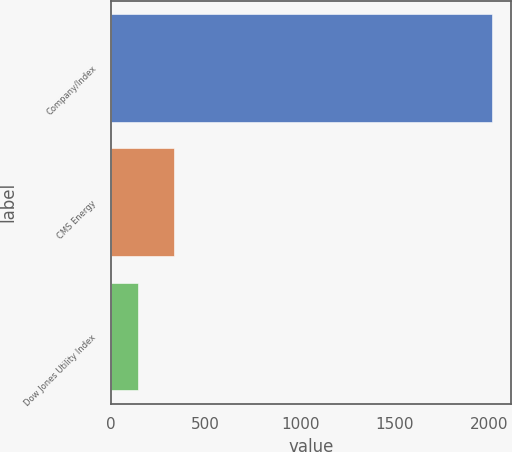Convert chart to OTSL. <chart><loc_0><loc_0><loc_500><loc_500><bar_chart><fcel>Company/Index<fcel>CMS Energy<fcel>Dow Jones Utility Index<nl><fcel>2015<fcel>330.2<fcel>143<nl></chart> 